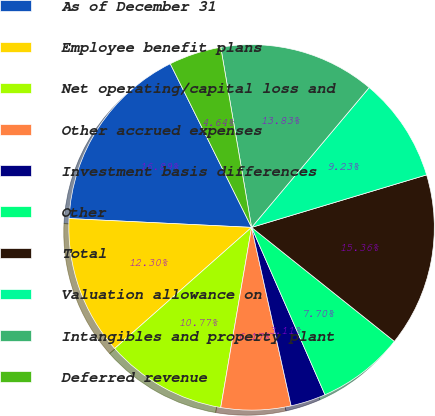Convert chart. <chart><loc_0><loc_0><loc_500><loc_500><pie_chart><fcel>As of December 31<fcel>Employee benefit plans<fcel>Net operating/capital loss and<fcel>Other accrued expenses<fcel>Investment basis differences<fcel>Other<fcel>Total<fcel>Valuation allowance on<fcel>Intangibles and property plant<fcel>Deferred revenue<nl><fcel>16.89%<fcel>12.3%<fcel>10.77%<fcel>6.17%<fcel>3.11%<fcel>7.7%<fcel>15.36%<fcel>9.23%<fcel>13.83%<fcel>4.64%<nl></chart> 